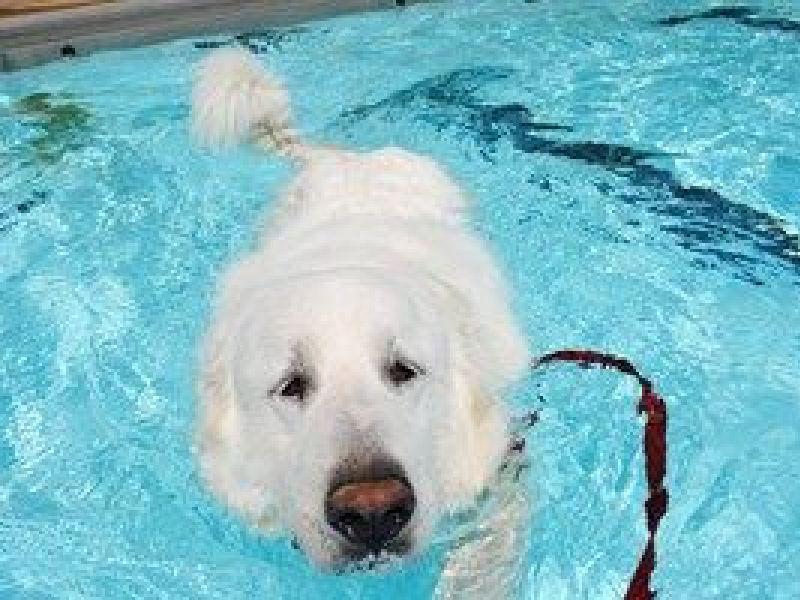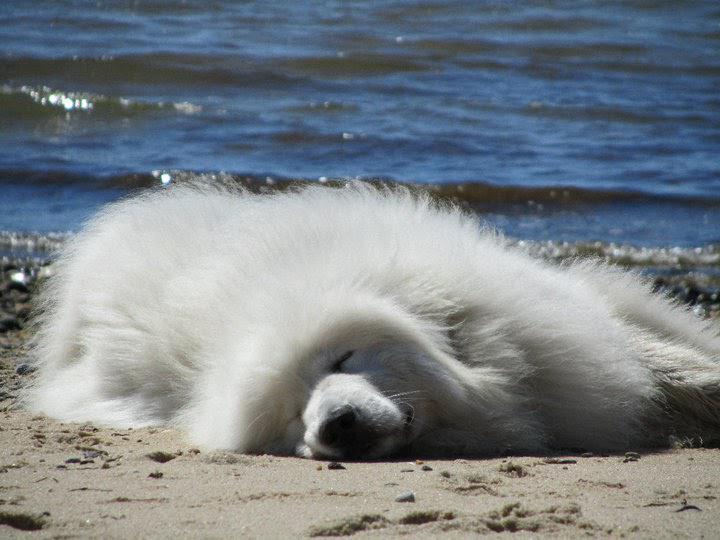The first image is the image on the left, the second image is the image on the right. Given the left and right images, does the statement "There is a person in the water in one of the images." hold true? Answer yes or no. No. The first image is the image on the left, the second image is the image on the right. For the images shown, is this caption "At least one image shows a dog actually swimming in a pool." true? Answer yes or no. Yes. 